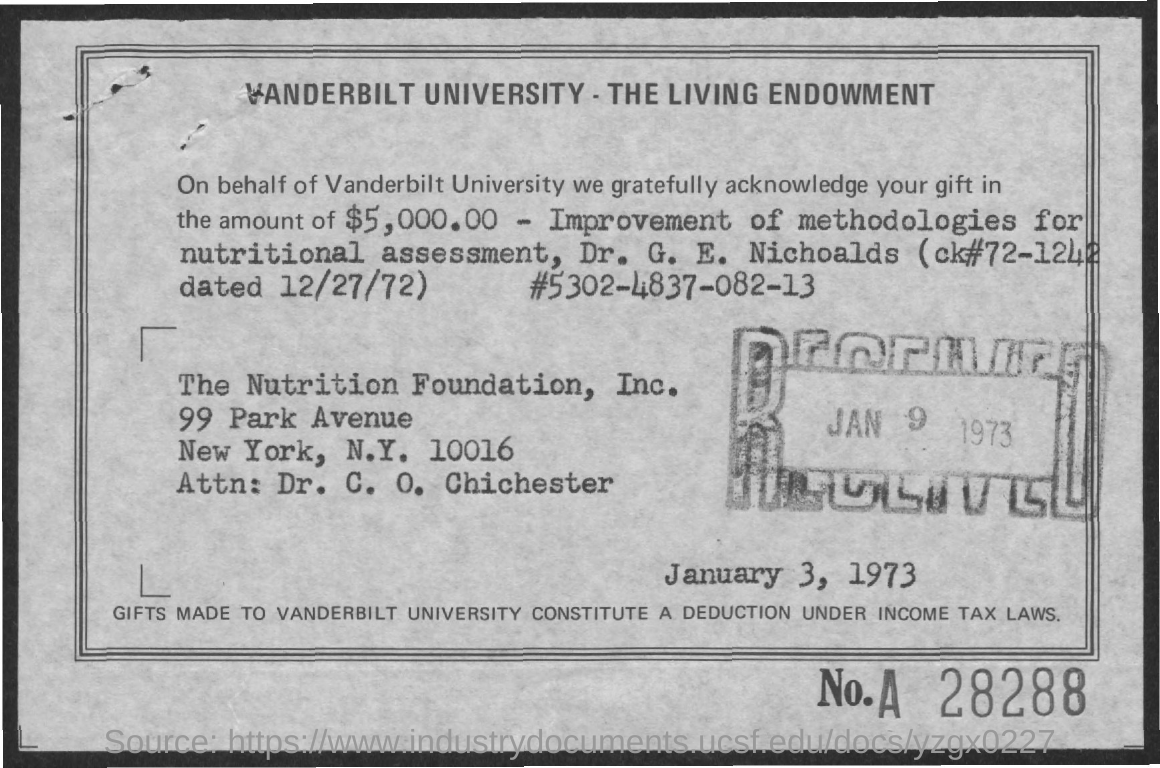Outline some significant characteristics in this image. The amount of the gift mentioned in the living endowment is $5,000.00. Vanderbilt University is the name of a university. On January 9th, 1973, the document was received. 